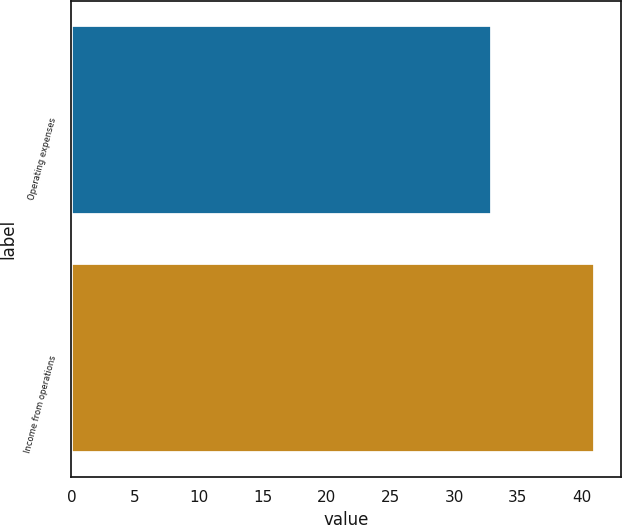Convert chart. <chart><loc_0><loc_0><loc_500><loc_500><bar_chart><fcel>Operating expenses<fcel>Income from operations<nl><fcel>33<fcel>41<nl></chart> 